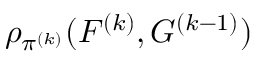Convert formula to latex. <formula><loc_0><loc_0><loc_500><loc_500>\rho _ { \pi ^ { ( k ) } } ( F ^ { ( k ) } , G ^ { ( k - 1 ) } )</formula> 